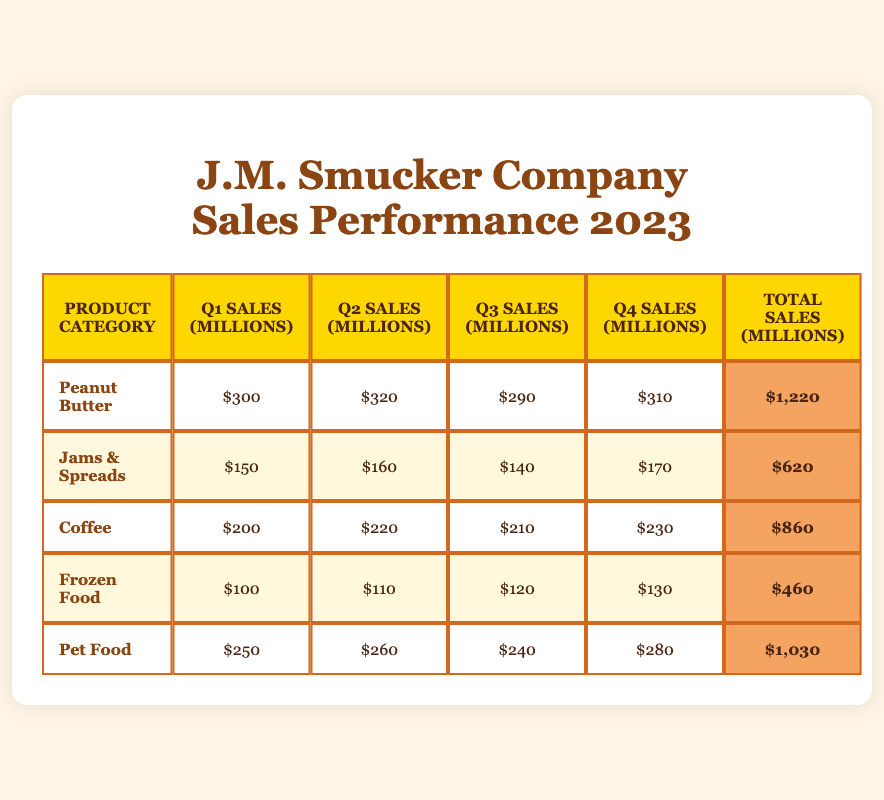What was the total sales for Peanut Butter in 2023? The total sales for Peanut Butter in 2023 can be found in the "Total Sales" column for that product category. It shows a value of $1,220 million.
Answer: 1,220 million Which product category had the highest sales in Q3? To find the highest sales in Q3, we should compare the sales values of all product categories in the Q3 column. The values are: Peanut Butter (290), Jams & Spreads (140), Coffee (210), Frozen Food (120), and Pet Food (240). The highest value is Peanut Butter at 290 million.
Answer: Peanut Butter How much more did Pet Food sell compared to Jams & Spreads in total sales? We will find the total sales figures for both Pet Food and Jams & Spreads from the respective "Total Sales" column. Pet Food has $1,030 million and Jams & Spreads has $620 million. The difference is $1,030 - $620 = $410 million.
Answer: 410 million Was the Q4 sales for Coffee greater than or equal to its Q1 sales? We check the Q4 sales for Coffee, which is $230 million, and compare it with the Q1 sales of $200 million. Since $230 million is greater than $200 million, the answer is yes.
Answer: Yes What is the average sales for Frozen Food across all quarters? The average sales can be calculated by summing the sales figures for Frozen Food across all quarters and dividing by the number of quarters. The sales are: Q1 (100), Q2 (110), Q3 (120), Q4 (130). The total is 100 + 110 + 120 + 130 = 460 million. There are 4 quarters, so the average sales is 460/4 = 115 million.
Answer: 115 million Which product category had the highest total sales? To determine which category had the highest total sales, we need to look at the "Total Sales" column. The total sales figures are: Peanut Butter ($1,220 million), Jams & Spreads ($620 million), Coffee ($860 million), Frozen Food ($460 million), and Pet Food ($1,030 million). The highest is Peanut Butter at $1,220 million.
Answer: Peanut Butter What were the Q2 sales for Jams & Spreads? We can refer to the Q2 sales column specifically for Jams & Spreads. According to the table, it shows a sales value of $160 million.
Answer: 160 million Is the total sales for Frozen Food greater than that of Coffee? Frozen Food's total sales amount is $460 million, while Coffee's total sales amount is $860 million. Since $460 million is less than $860 million, the answer is no.
Answer: No 